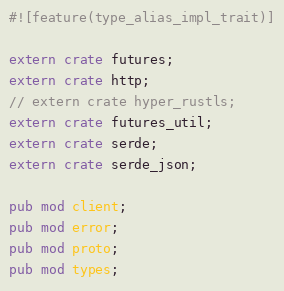<code> <loc_0><loc_0><loc_500><loc_500><_Rust_>#![feature(type_alias_impl_trait)]

extern crate futures;
extern crate http;
// extern crate hyper_rustls;
extern crate futures_util;
extern crate serde;
extern crate serde_json;

pub mod client;
pub mod error;
pub mod proto;
pub mod types;
</code> 